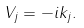Convert formula to latex. <formula><loc_0><loc_0><loc_500><loc_500>V _ { j } = - i k _ { j } .</formula> 